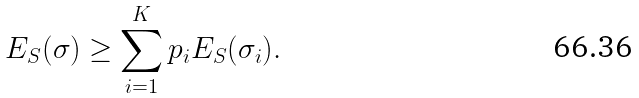Convert formula to latex. <formula><loc_0><loc_0><loc_500><loc_500>E _ { S } ( \sigma ) \geq \sum _ { i = 1 } ^ { K } p _ { i } E _ { S } ( \sigma _ { i } ) .</formula> 